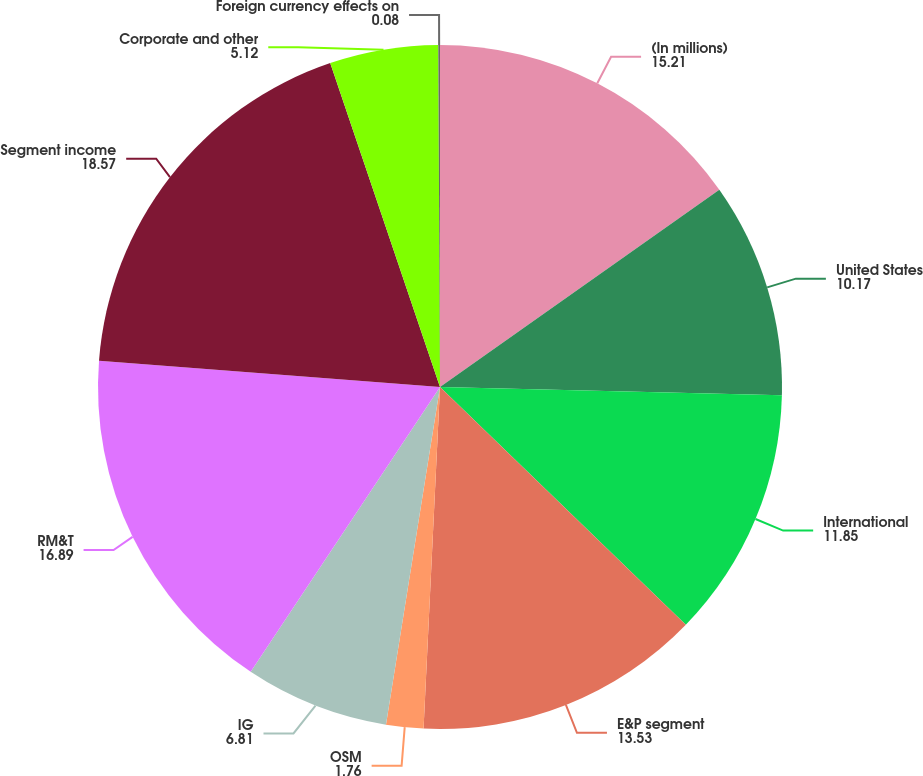<chart> <loc_0><loc_0><loc_500><loc_500><pie_chart><fcel>(In millions)<fcel>United States<fcel>International<fcel>E&P segment<fcel>OSM<fcel>IG<fcel>RM&T<fcel>Segment income<fcel>Corporate and other<fcel>Foreign currency effects on<nl><fcel>15.21%<fcel>10.17%<fcel>11.85%<fcel>13.53%<fcel>1.76%<fcel>6.81%<fcel>16.89%<fcel>18.57%<fcel>5.12%<fcel>0.08%<nl></chart> 